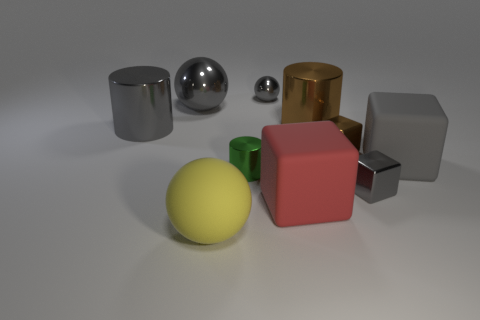What size is the matte block on the right side of the cylinder that is to the right of the small shiny cylinder?
Ensure brevity in your answer.  Large. Is the number of large shiny objects greater than the number of rubber spheres?
Your answer should be very brief. Yes. Is the number of gray metal cylinders on the left side of the red matte thing greater than the number of gray shiny objects on the right side of the small sphere?
Provide a short and direct response. No. How big is the gray thing that is on the left side of the gray matte block and on the right side of the small gray metal ball?
Give a very brief answer. Small. How many gray matte things are the same size as the brown metal cylinder?
Your response must be concise. 1. There is another ball that is the same color as the tiny metal sphere; what is it made of?
Offer a terse response. Metal. Is the shape of the rubber thing that is to the right of the tiny brown metal block the same as  the yellow object?
Your response must be concise. No. Are there fewer big matte balls that are to the right of the small green shiny thing than gray metallic cylinders?
Your response must be concise. Yes. Are there any blocks of the same color as the tiny ball?
Your answer should be very brief. Yes. There is a big gray matte object; does it have the same shape as the tiny brown object right of the big red matte cube?
Your response must be concise. Yes. 